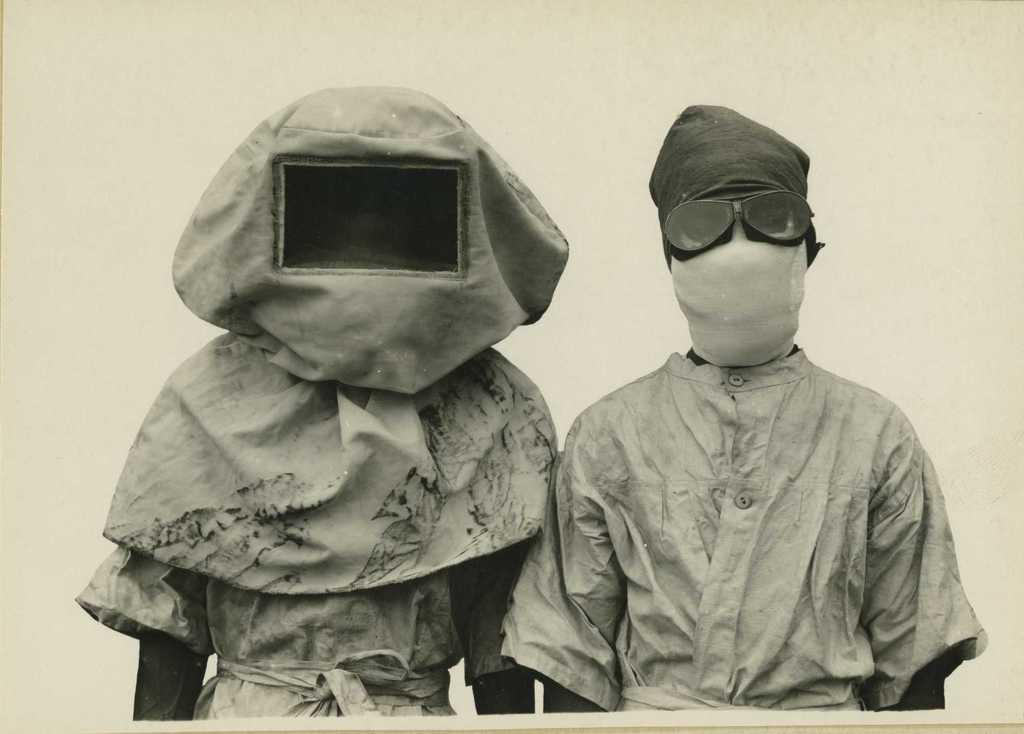How many people are in the image? There are two persons in the image. What are the persons wearing? The persons are wearing clothes and masks. What type of stone is the animal sitting on in the image? There is no animal or stone present in the image; it features two persons wearing masks. 